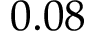<formula> <loc_0><loc_0><loc_500><loc_500>0 . 0 8</formula> 